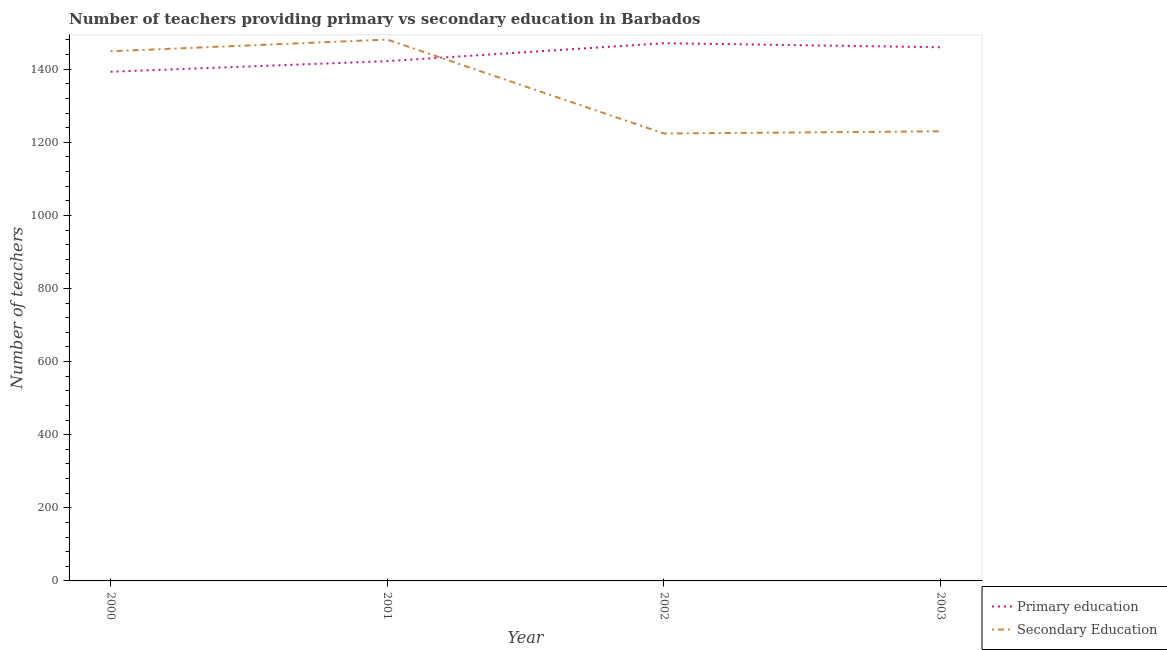Is the number of lines equal to the number of legend labels?
Offer a very short reply. Yes. What is the number of secondary teachers in 2000?
Give a very brief answer. 1449. Across all years, what is the maximum number of primary teachers?
Keep it short and to the point. 1471. Across all years, what is the minimum number of secondary teachers?
Provide a short and direct response. 1224. In which year was the number of primary teachers maximum?
Offer a very short reply. 2002. In which year was the number of secondary teachers minimum?
Your response must be concise. 2002. What is the total number of primary teachers in the graph?
Keep it short and to the point. 5746. What is the difference between the number of secondary teachers in 2001 and that in 2003?
Offer a very short reply. 251. What is the difference between the number of primary teachers in 2003 and the number of secondary teachers in 2000?
Keep it short and to the point. 11. What is the average number of primary teachers per year?
Your answer should be compact. 1436.5. In the year 2003, what is the difference between the number of secondary teachers and number of primary teachers?
Ensure brevity in your answer.  -230. What is the ratio of the number of secondary teachers in 2000 to that in 2003?
Offer a terse response. 1.18. What is the difference between the highest and the second highest number of secondary teachers?
Your response must be concise. 32. What is the difference between the highest and the lowest number of primary teachers?
Your answer should be compact. 78. Is the sum of the number of secondary teachers in 2000 and 2002 greater than the maximum number of primary teachers across all years?
Offer a terse response. Yes. Does the number of primary teachers monotonically increase over the years?
Ensure brevity in your answer.  No. Is the number of secondary teachers strictly greater than the number of primary teachers over the years?
Your answer should be very brief. No. How many lines are there?
Provide a short and direct response. 2. What is the difference between two consecutive major ticks on the Y-axis?
Keep it short and to the point. 200. Are the values on the major ticks of Y-axis written in scientific E-notation?
Make the answer very short. No. Does the graph contain grids?
Your response must be concise. No. Where does the legend appear in the graph?
Your answer should be compact. Bottom right. How many legend labels are there?
Your response must be concise. 2. How are the legend labels stacked?
Offer a very short reply. Vertical. What is the title of the graph?
Offer a terse response. Number of teachers providing primary vs secondary education in Barbados. Does "Resident" appear as one of the legend labels in the graph?
Provide a short and direct response. No. What is the label or title of the X-axis?
Provide a short and direct response. Year. What is the label or title of the Y-axis?
Give a very brief answer. Number of teachers. What is the Number of teachers in Primary education in 2000?
Your answer should be compact. 1393. What is the Number of teachers in Secondary Education in 2000?
Make the answer very short. 1449. What is the Number of teachers of Primary education in 2001?
Offer a terse response. 1422. What is the Number of teachers in Secondary Education in 2001?
Offer a terse response. 1481. What is the Number of teachers of Primary education in 2002?
Keep it short and to the point. 1471. What is the Number of teachers of Secondary Education in 2002?
Provide a succinct answer. 1224. What is the Number of teachers of Primary education in 2003?
Ensure brevity in your answer.  1460. What is the Number of teachers of Secondary Education in 2003?
Give a very brief answer. 1230. Across all years, what is the maximum Number of teachers of Primary education?
Offer a terse response. 1471. Across all years, what is the maximum Number of teachers in Secondary Education?
Provide a short and direct response. 1481. Across all years, what is the minimum Number of teachers of Primary education?
Your answer should be very brief. 1393. Across all years, what is the minimum Number of teachers in Secondary Education?
Your response must be concise. 1224. What is the total Number of teachers in Primary education in the graph?
Your answer should be very brief. 5746. What is the total Number of teachers of Secondary Education in the graph?
Provide a succinct answer. 5384. What is the difference between the Number of teachers in Primary education in 2000 and that in 2001?
Make the answer very short. -29. What is the difference between the Number of teachers of Secondary Education in 2000 and that in 2001?
Offer a very short reply. -32. What is the difference between the Number of teachers of Primary education in 2000 and that in 2002?
Give a very brief answer. -78. What is the difference between the Number of teachers of Secondary Education in 2000 and that in 2002?
Offer a terse response. 225. What is the difference between the Number of teachers of Primary education in 2000 and that in 2003?
Provide a short and direct response. -67. What is the difference between the Number of teachers of Secondary Education in 2000 and that in 2003?
Give a very brief answer. 219. What is the difference between the Number of teachers in Primary education in 2001 and that in 2002?
Keep it short and to the point. -49. What is the difference between the Number of teachers of Secondary Education in 2001 and that in 2002?
Your response must be concise. 257. What is the difference between the Number of teachers in Primary education in 2001 and that in 2003?
Your answer should be compact. -38. What is the difference between the Number of teachers in Secondary Education in 2001 and that in 2003?
Give a very brief answer. 251. What is the difference between the Number of teachers of Primary education in 2002 and that in 2003?
Your answer should be very brief. 11. What is the difference between the Number of teachers in Primary education in 2000 and the Number of teachers in Secondary Education in 2001?
Offer a very short reply. -88. What is the difference between the Number of teachers in Primary education in 2000 and the Number of teachers in Secondary Education in 2002?
Ensure brevity in your answer.  169. What is the difference between the Number of teachers of Primary education in 2000 and the Number of teachers of Secondary Education in 2003?
Your response must be concise. 163. What is the difference between the Number of teachers of Primary education in 2001 and the Number of teachers of Secondary Education in 2002?
Keep it short and to the point. 198. What is the difference between the Number of teachers in Primary education in 2001 and the Number of teachers in Secondary Education in 2003?
Keep it short and to the point. 192. What is the difference between the Number of teachers in Primary education in 2002 and the Number of teachers in Secondary Education in 2003?
Your response must be concise. 241. What is the average Number of teachers of Primary education per year?
Your response must be concise. 1436.5. What is the average Number of teachers in Secondary Education per year?
Keep it short and to the point. 1346. In the year 2000, what is the difference between the Number of teachers in Primary education and Number of teachers in Secondary Education?
Offer a very short reply. -56. In the year 2001, what is the difference between the Number of teachers in Primary education and Number of teachers in Secondary Education?
Provide a short and direct response. -59. In the year 2002, what is the difference between the Number of teachers in Primary education and Number of teachers in Secondary Education?
Your response must be concise. 247. In the year 2003, what is the difference between the Number of teachers of Primary education and Number of teachers of Secondary Education?
Keep it short and to the point. 230. What is the ratio of the Number of teachers in Primary education in 2000 to that in 2001?
Ensure brevity in your answer.  0.98. What is the ratio of the Number of teachers in Secondary Education in 2000 to that in 2001?
Your answer should be very brief. 0.98. What is the ratio of the Number of teachers of Primary education in 2000 to that in 2002?
Provide a short and direct response. 0.95. What is the ratio of the Number of teachers of Secondary Education in 2000 to that in 2002?
Ensure brevity in your answer.  1.18. What is the ratio of the Number of teachers in Primary education in 2000 to that in 2003?
Provide a succinct answer. 0.95. What is the ratio of the Number of teachers in Secondary Education in 2000 to that in 2003?
Offer a terse response. 1.18. What is the ratio of the Number of teachers in Primary education in 2001 to that in 2002?
Your answer should be very brief. 0.97. What is the ratio of the Number of teachers of Secondary Education in 2001 to that in 2002?
Make the answer very short. 1.21. What is the ratio of the Number of teachers in Primary education in 2001 to that in 2003?
Provide a short and direct response. 0.97. What is the ratio of the Number of teachers of Secondary Education in 2001 to that in 2003?
Keep it short and to the point. 1.2. What is the ratio of the Number of teachers in Primary education in 2002 to that in 2003?
Provide a short and direct response. 1.01. What is the ratio of the Number of teachers of Secondary Education in 2002 to that in 2003?
Give a very brief answer. 1. What is the difference between the highest and the second highest Number of teachers of Secondary Education?
Your answer should be compact. 32. What is the difference between the highest and the lowest Number of teachers of Secondary Education?
Offer a terse response. 257. 